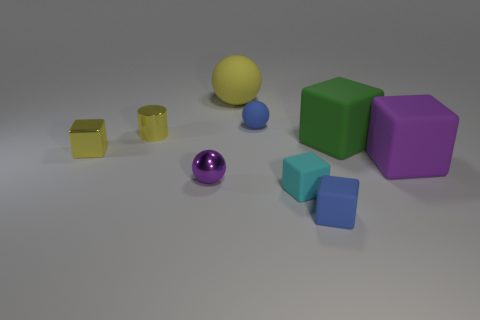What color is the tiny cylinder that is the same material as the small purple object? yellow 